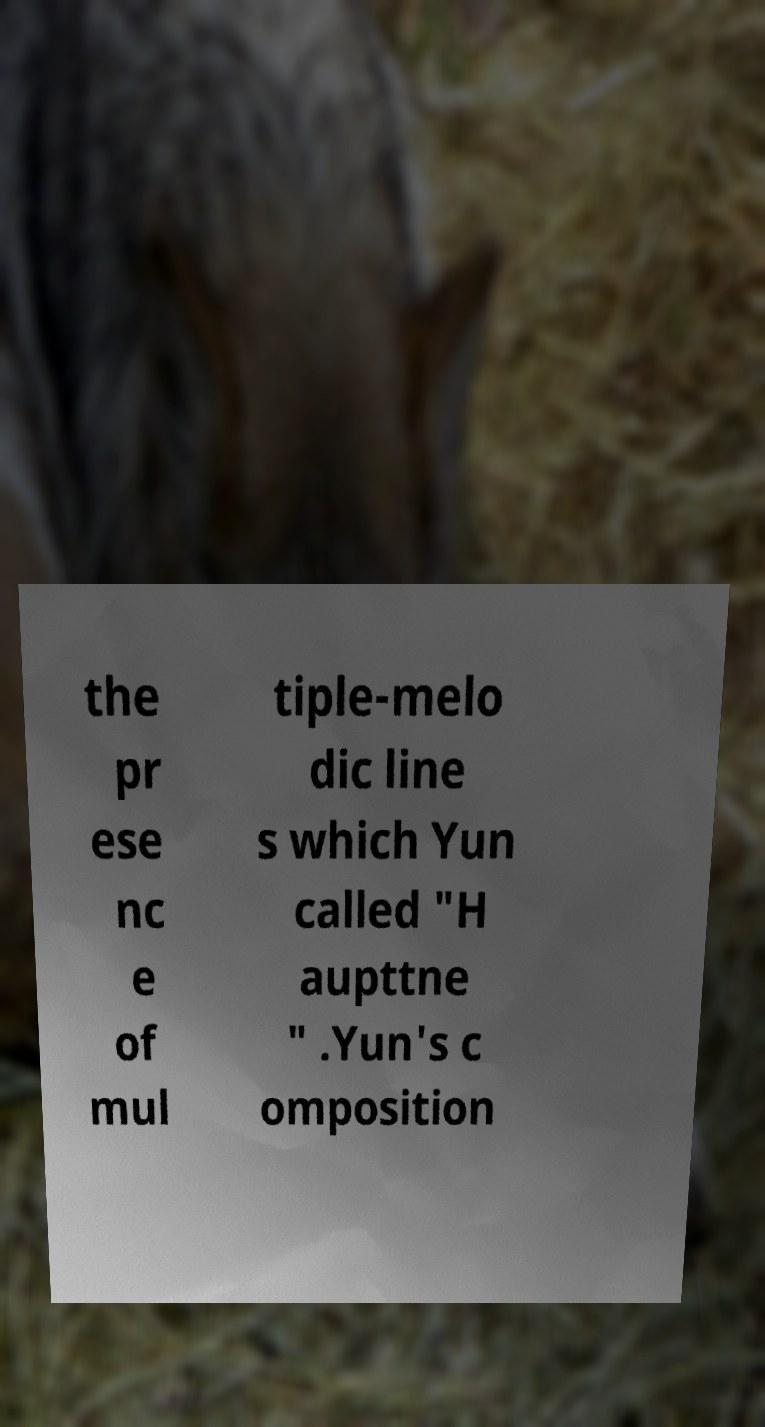Can you read and provide the text displayed in the image?This photo seems to have some interesting text. Can you extract and type it out for me? the pr ese nc e of mul tiple-melo dic line s which Yun called "H aupttne " .Yun's c omposition 